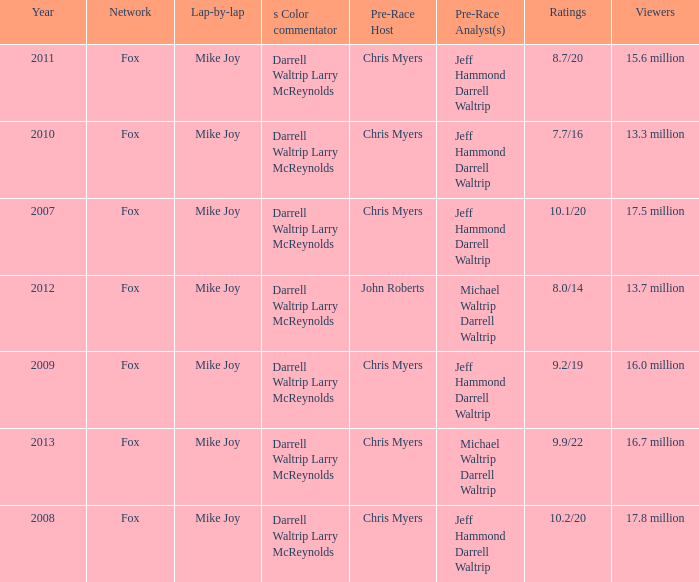What Lap-by-lap has Chris Myers as the Pre-Race Host, a Year larger than 2008, and 9.9/22 as its Ratings? Mike Joy. 